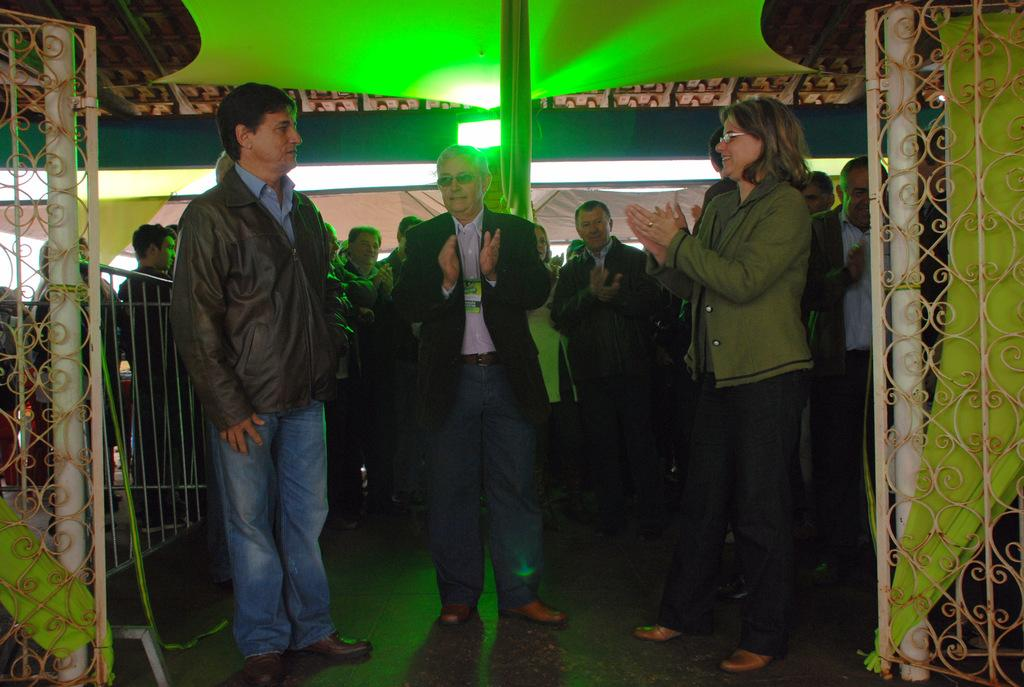What are the people in the image doing? The people in the image are standing and clapping their hands. What can be seen in the background of the image? There are electric lights, a curtain, and a gate in the background of the image. What type of toys are the people playing with in the image? There are no toys present in the image; the people are clapping their hands. How many thumbs does the person on the left have in the image? We cannot determine the number of thumbs the person on the left has in the image, as it is not possible to count them from the provided information. 